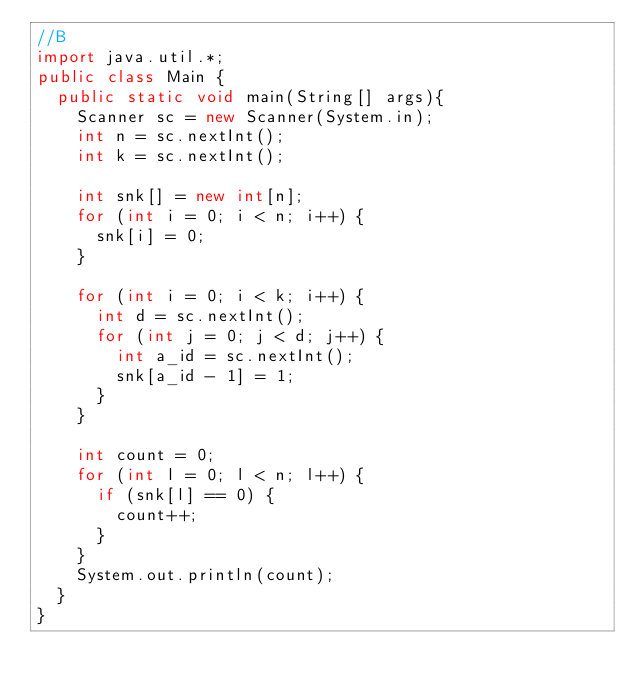Convert code to text. <code><loc_0><loc_0><loc_500><loc_500><_Java_>//B
import java.util.*;
public class Main {
	public static void main(String[] args){
		Scanner sc = new Scanner(System.in);
		int n = sc.nextInt();
		int k = sc.nextInt();
		
		int snk[] = new int[n];
		for (int i = 0; i < n; i++) {
			snk[i] = 0;
		}
		
		for (int i = 0; i < k; i++) {
			int d = sc.nextInt();
			for (int j = 0; j < d; j++) {
				int a_id = sc.nextInt();
				snk[a_id - 1] = 1;
			}
		}
		
		int count = 0;
		for (int l = 0; l < n; l++) {
			if (snk[l] == 0) {
				count++;
			}
		}
		System.out.println(count);
	}
}</code> 